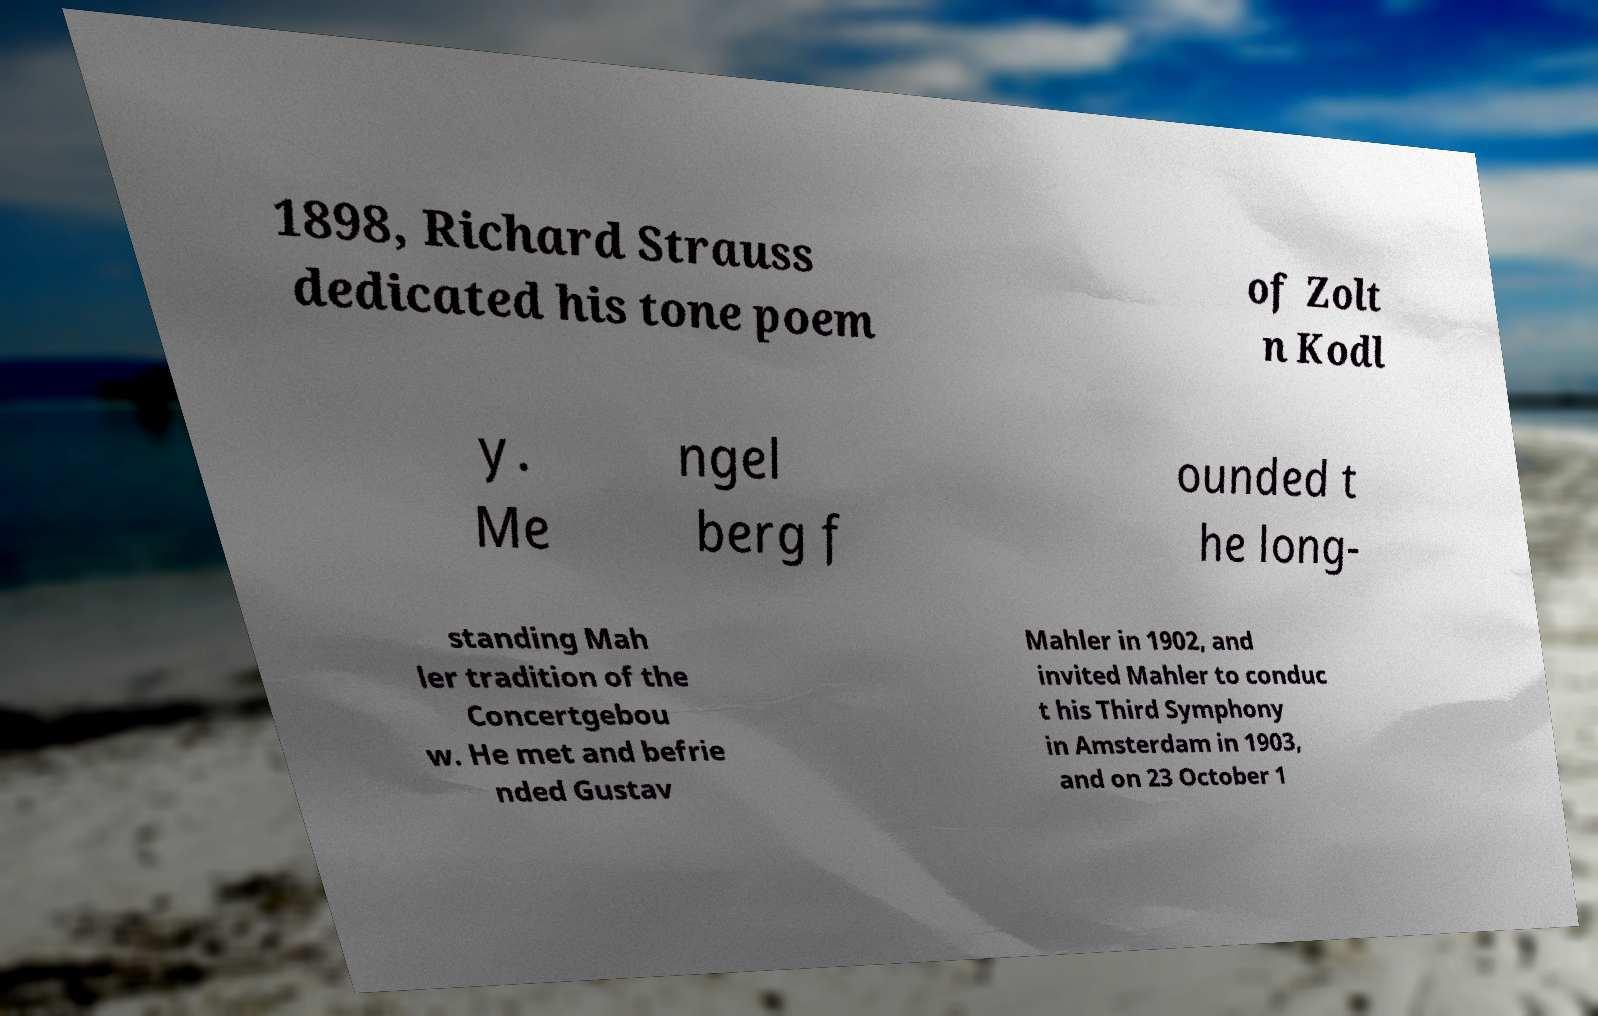Could you assist in decoding the text presented in this image and type it out clearly? 1898, Richard Strauss dedicated his tone poem of Zolt n Kodl y. Me ngel berg f ounded t he long- standing Mah ler tradition of the Concertgebou w. He met and befrie nded Gustav Mahler in 1902, and invited Mahler to conduc t his Third Symphony in Amsterdam in 1903, and on 23 October 1 